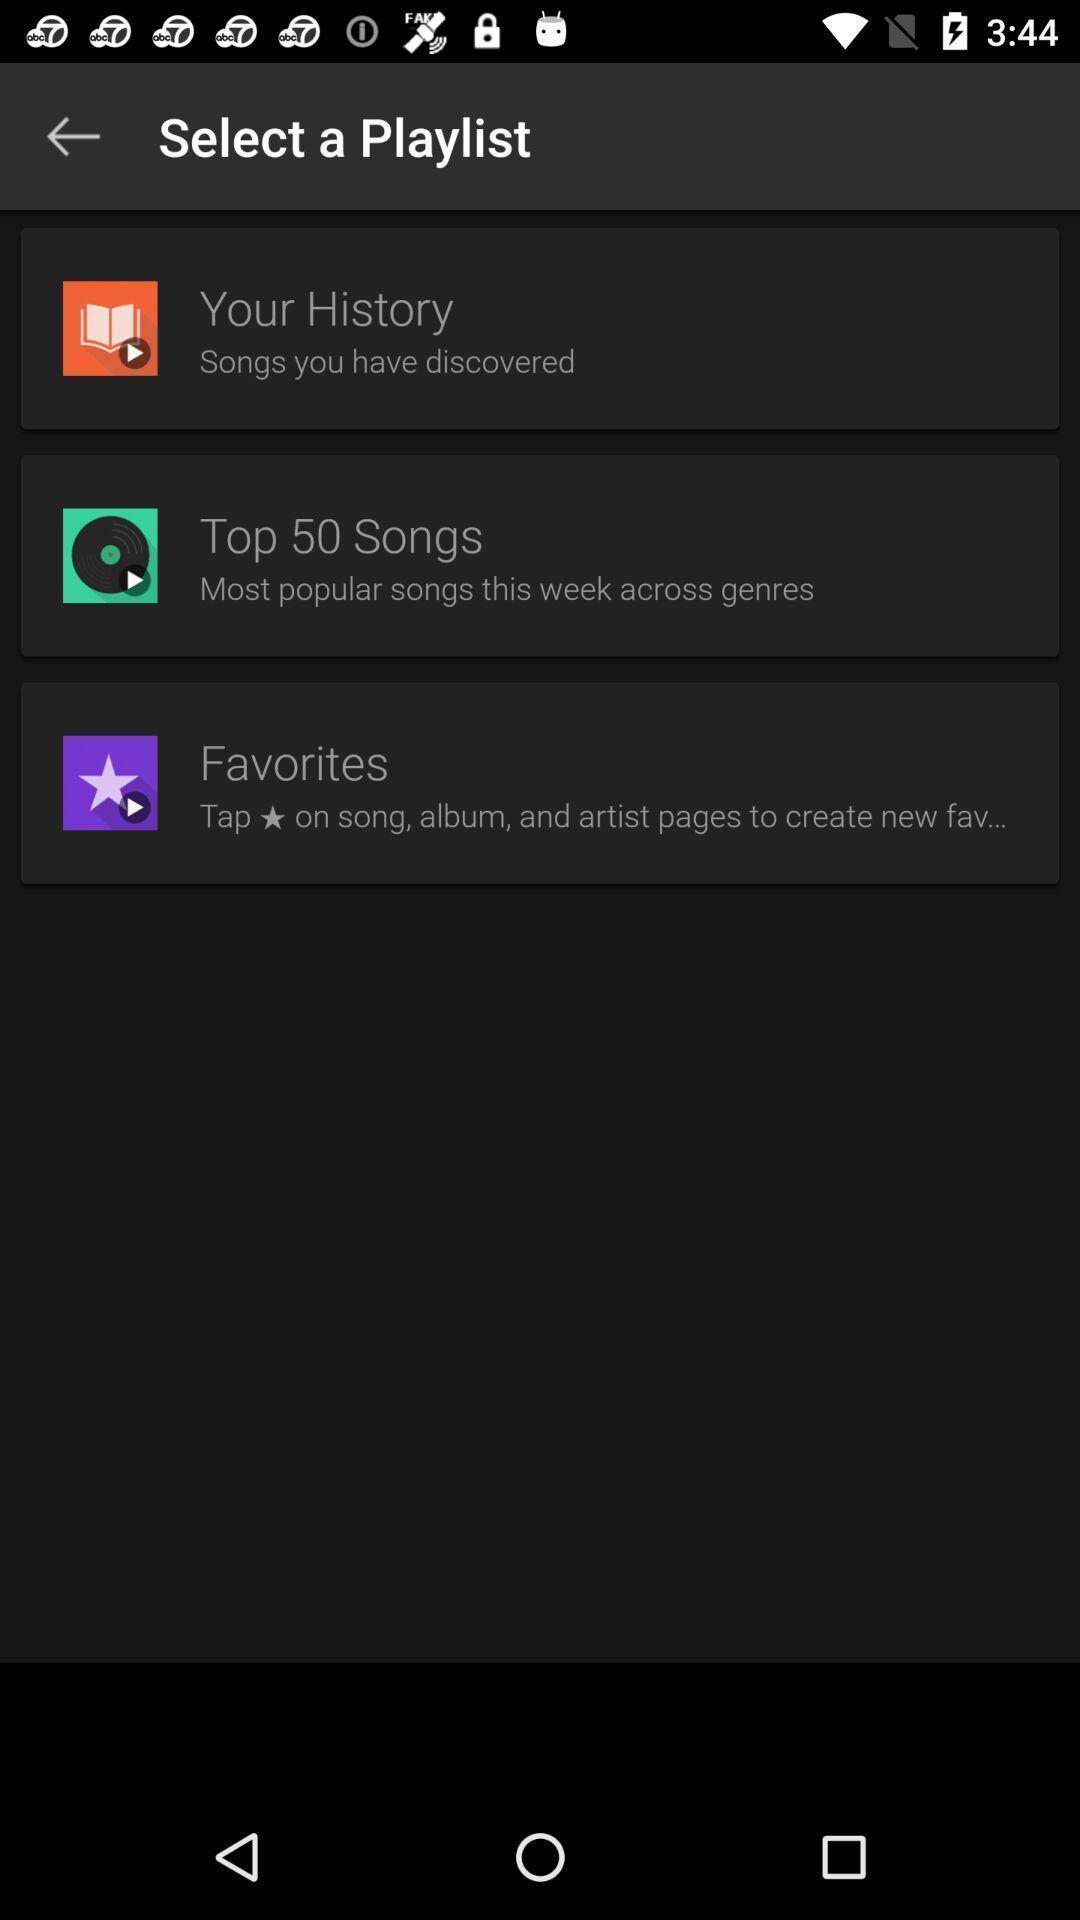Provide a textual representation of this image. Screen shows select a playlist in music app. 